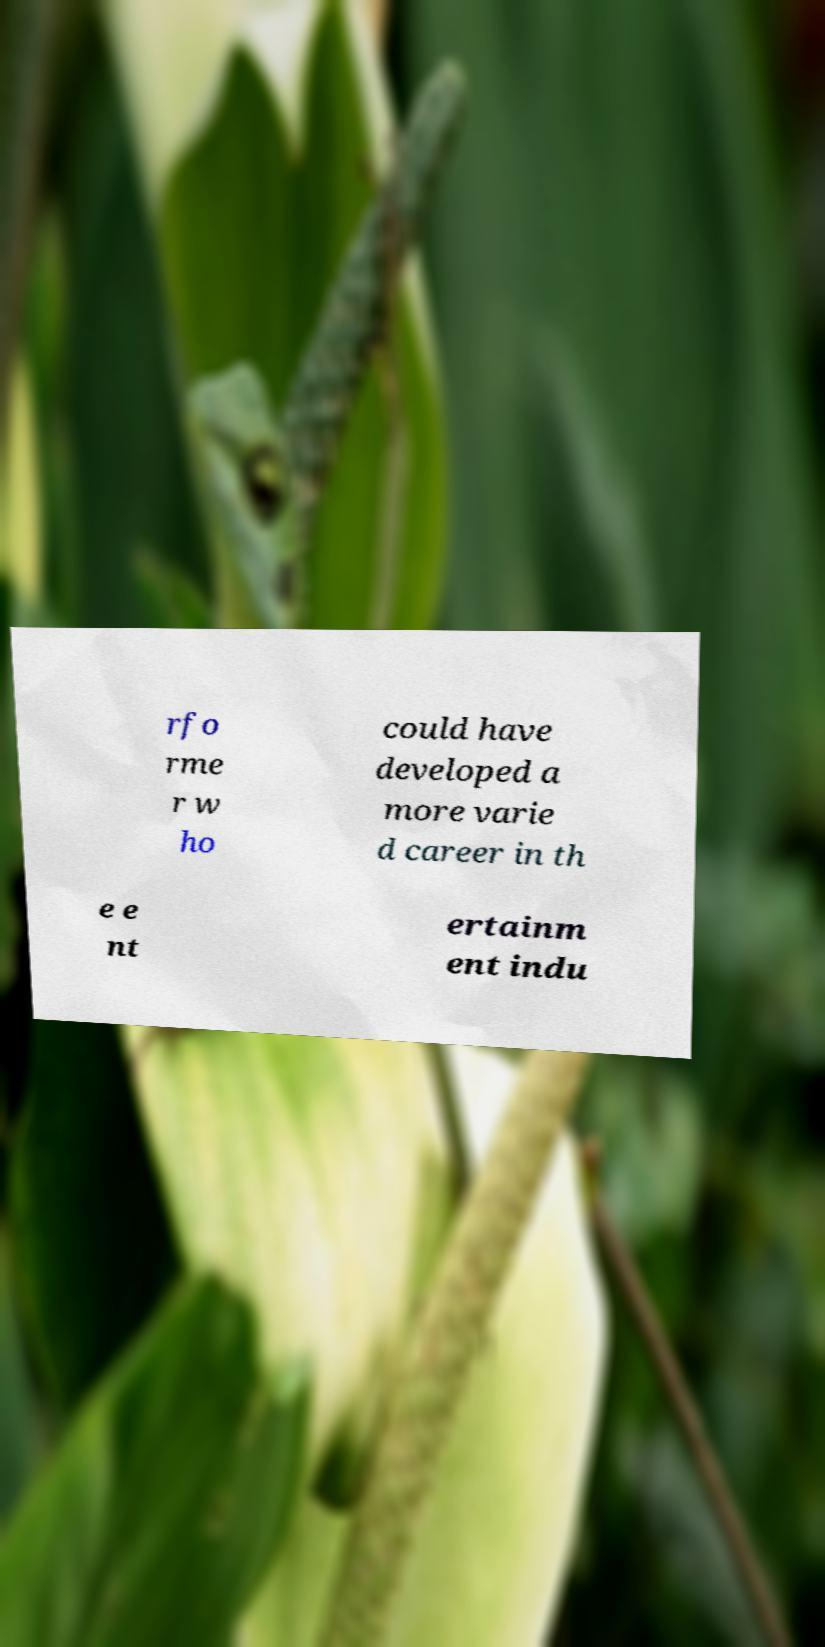Please identify and transcribe the text found in this image. rfo rme r w ho could have developed a more varie d career in th e e nt ertainm ent indu 